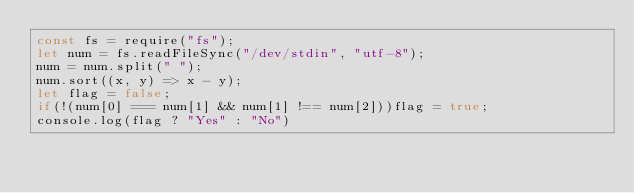Convert code to text. <code><loc_0><loc_0><loc_500><loc_500><_JavaScript_>const fs = require("fs");
let num = fs.readFileSync("/dev/stdin", "utf-8");
num = num.split(" ");
num.sort((x, y) => x - y);
let flag = false;
if(!(num[0] === num[1] && num[1] !== num[2]))flag = true;
console.log(flag ? "Yes" : "No")
</code> 